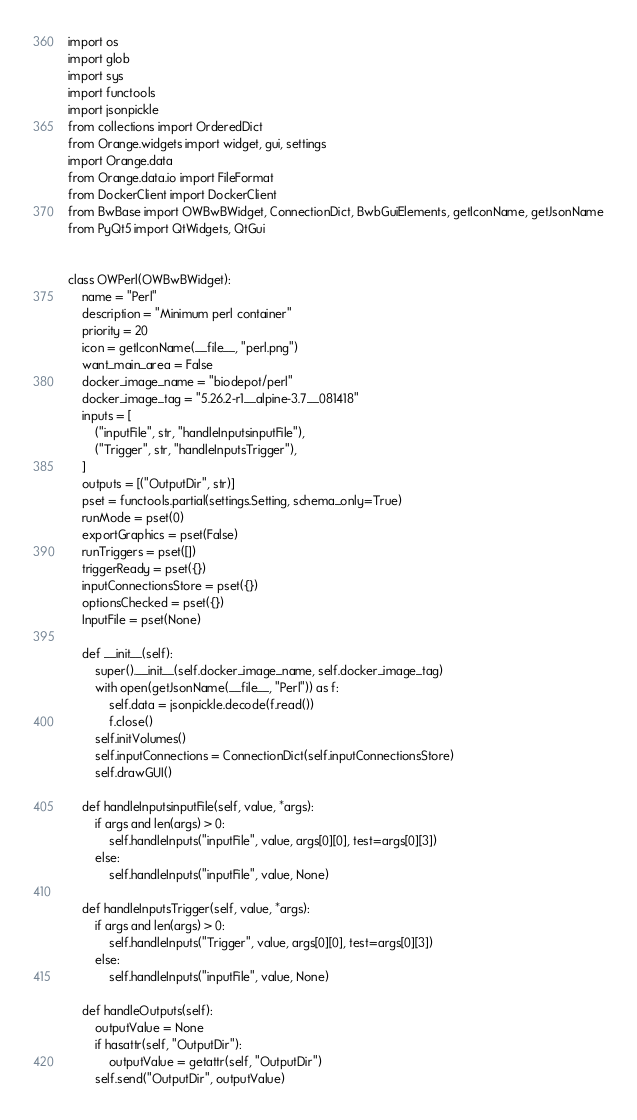<code> <loc_0><loc_0><loc_500><loc_500><_Python_>import os
import glob
import sys
import functools
import jsonpickle
from collections import OrderedDict
from Orange.widgets import widget, gui, settings
import Orange.data
from Orange.data.io import FileFormat
from DockerClient import DockerClient
from BwBase import OWBwBWidget, ConnectionDict, BwbGuiElements, getIconName, getJsonName
from PyQt5 import QtWidgets, QtGui


class OWPerl(OWBwBWidget):
    name = "Perl"
    description = "Minimum perl container"
    priority = 20
    icon = getIconName(__file__, "perl.png")
    want_main_area = False
    docker_image_name = "biodepot/perl"
    docker_image_tag = "5.26.2-r1__alpine-3.7__081418"
    inputs = [
        ("inputFile", str, "handleInputsinputFile"),
        ("Trigger", str, "handleInputsTrigger"),
    ]
    outputs = [("OutputDir", str)]
    pset = functools.partial(settings.Setting, schema_only=True)
    runMode = pset(0)
    exportGraphics = pset(False)
    runTriggers = pset([])
    triggerReady = pset({})
    inputConnectionsStore = pset({})
    optionsChecked = pset({})
    InputFile = pset(None)

    def __init__(self):
        super().__init__(self.docker_image_name, self.docker_image_tag)
        with open(getJsonName(__file__, "Perl")) as f:
            self.data = jsonpickle.decode(f.read())
            f.close()
        self.initVolumes()
        self.inputConnections = ConnectionDict(self.inputConnectionsStore)
        self.drawGUI()

    def handleInputsinputFile(self, value, *args):
        if args and len(args) > 0:
            self.handleInputs("inputFile", value, args[0][0], test=args[0][3])
        else:
            self.handleInputs("inputFile", value, None)

    def handleInputsTrigger(self, value, *args):
        if args and len(args) > 0:
            self.handleInputs("Trigger", value, args[0][0], test=args[0][3])
        else:
            self.handleInputs("inputFile", value, None)

    def handleOutputs(self):
        outputValue = None
        if hasattr(self, "OutputDir"):
            outputValue = getattr(self, "OutputDir")
        self.send("OutputDir", outputValue)
</code> 